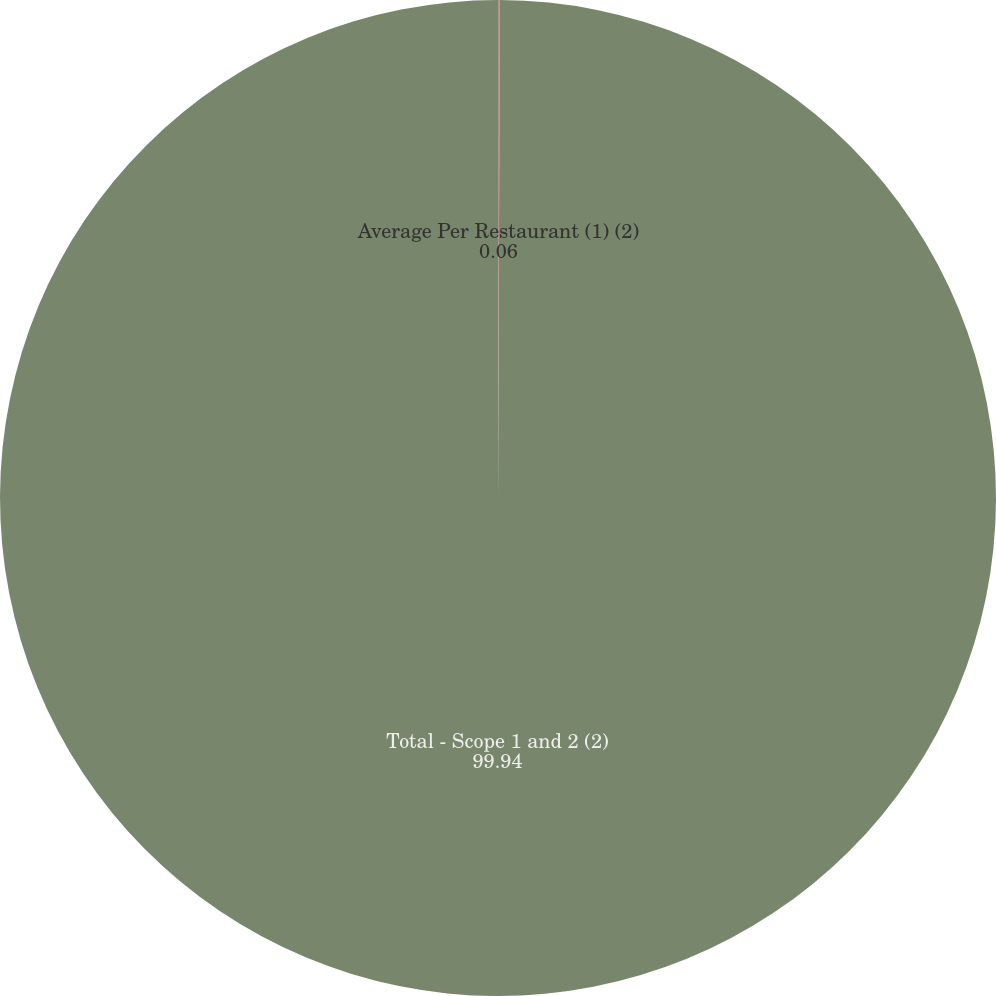<chart> <loc_0><loc_0><loc_500><loc_500><pie_chart><fcel>Average Per Restaurant (1) (2)<fcel>Total - Scope 1 and 2 (2)<nl><fcel>0.06%<fcel>99.94%<nl></chart> 